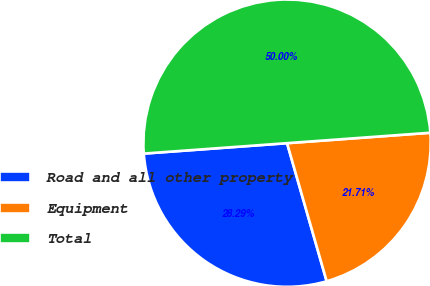Convert chart to OTSL. <chart><loc_0><loc_0><loc_500><loc_500><pie_chart><fcel>Road and all other property<fcel>Equipment<fcel>Total<nl><fcel>28.29%<fcel>21.71%<fcel>50.0%<nl></chart> 